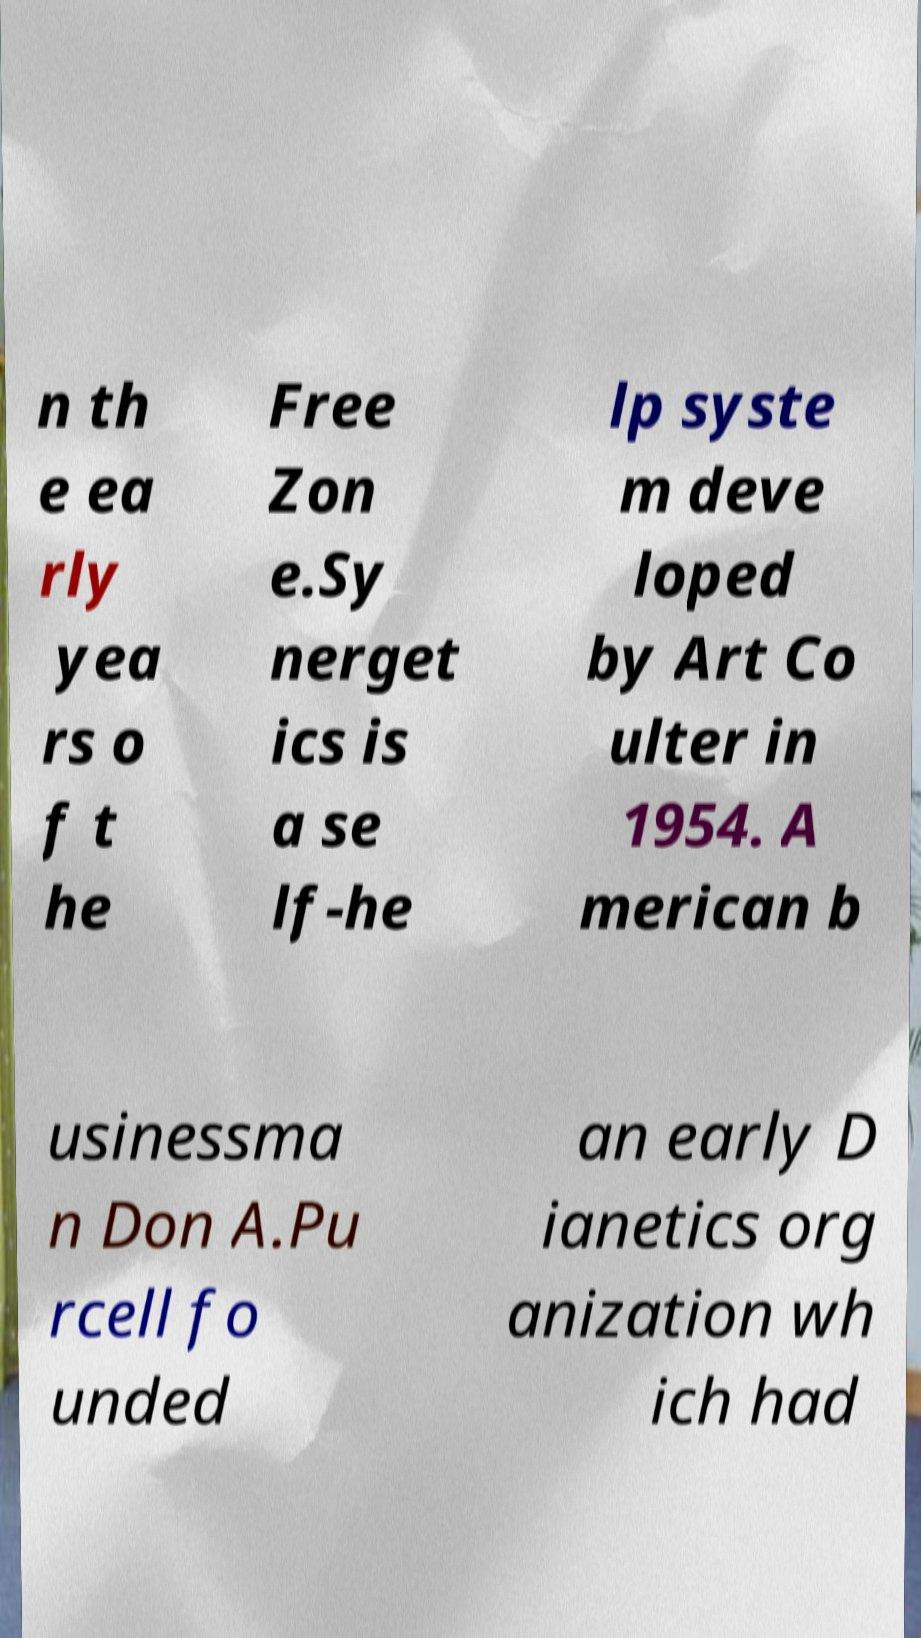Please identify and transcribe the text found in this image. n th e ea rly yea rs o f t he Free Zon e.Sy nerget ics is a se lf-he lp syste m deve loped by Art Co ulter in 1954. A merican b usinessma n Don A.Pu rcell fo unded an early D ianetics org anization wh ich had 